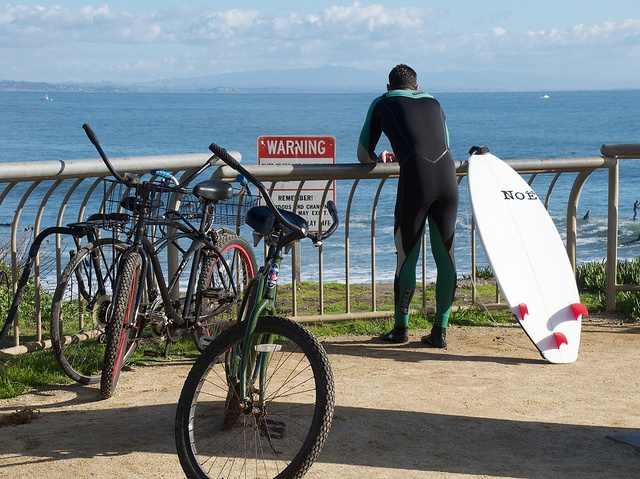Describe the objects in this image and their specific colors. I can see bicycle in lightblue, black, gray, and tan tones, bicycle in lightblue, black, gray, and darkgray tones, people in lightblue, black, gray, and teal tones, surfboard in lightblue, white, darkgray, salmon, and brown tones, and bicycle in lightblue, black, gray, darkgreen, and darkgray tones in this image. 